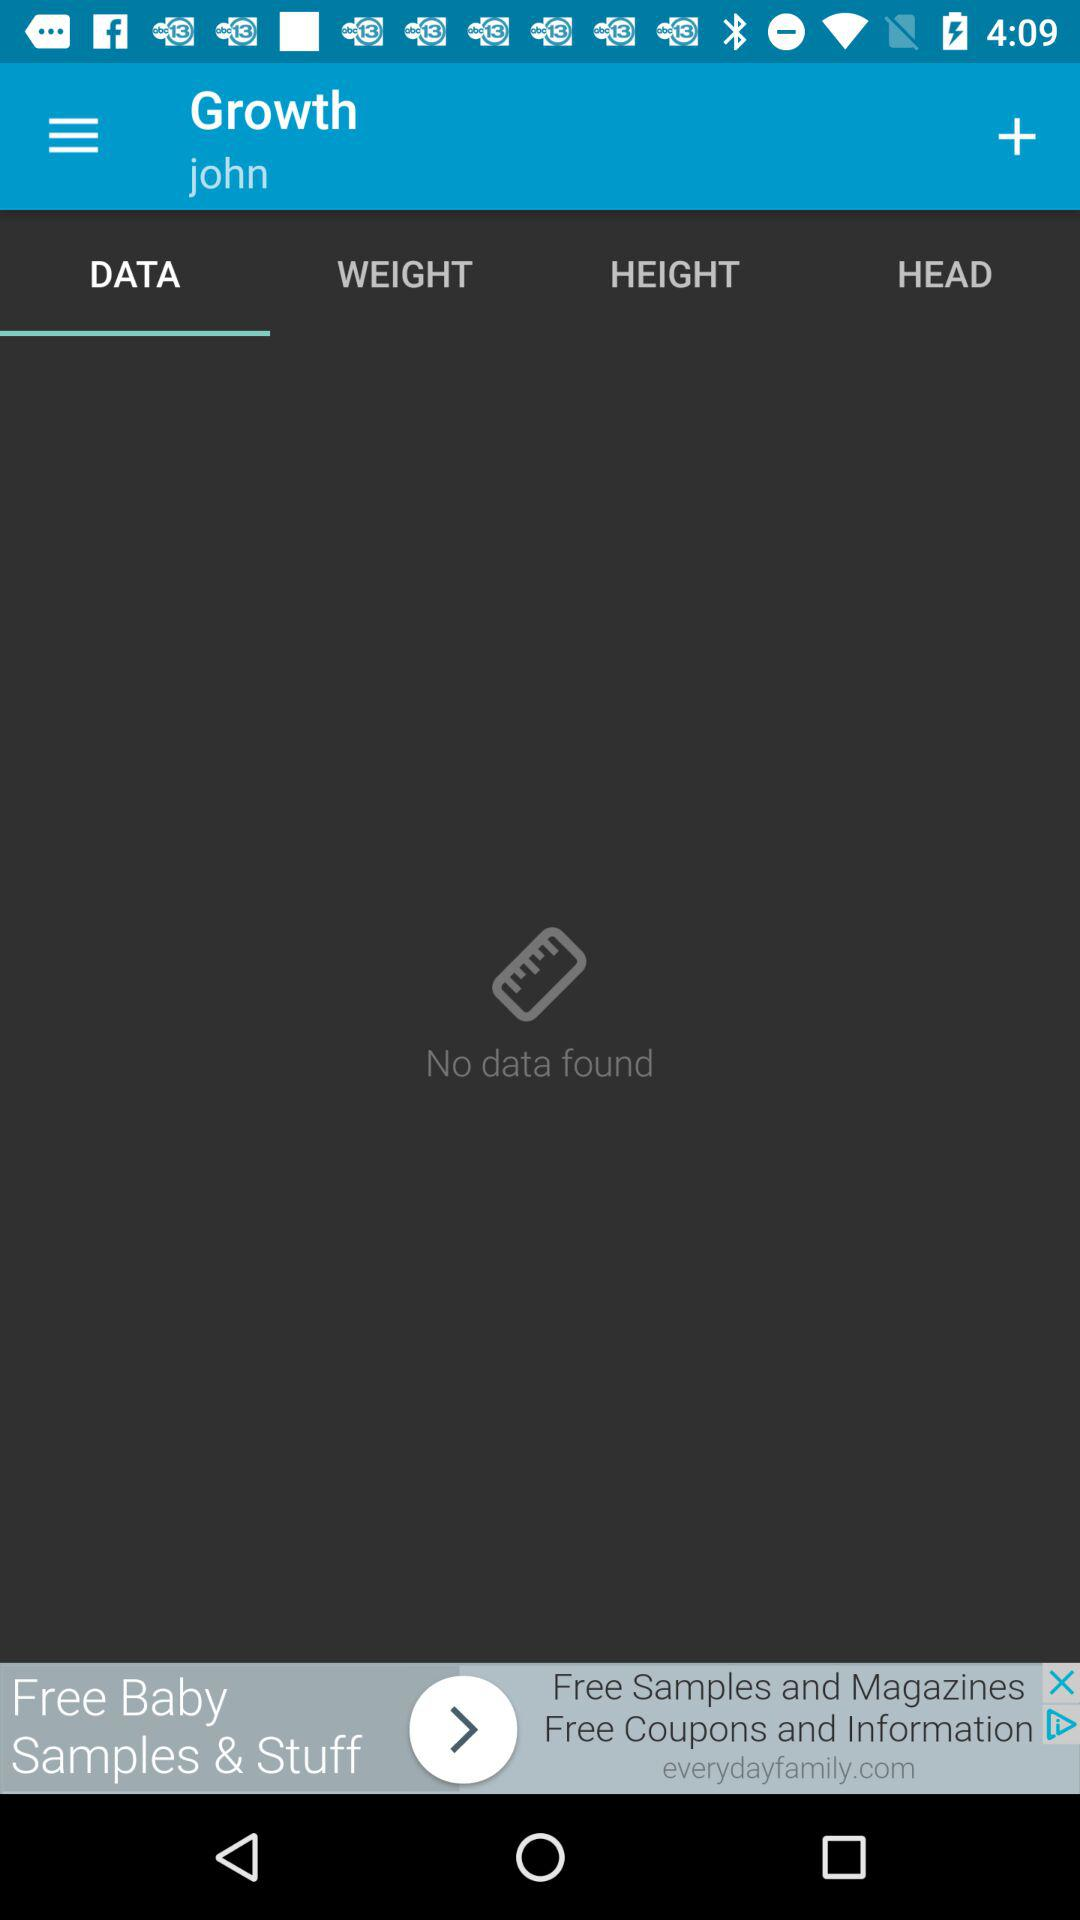What is the name of the user? The user name is John. 